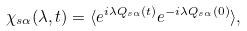<formula> <loc_0><loc_0><loc_500><loc_500>\chi _ { s \alpha } ( \lambda , t ) = \langle e ^ { i \lambda Q _ { s \alpha } ( t ) } e ^ { - i \lambda Q _ { s \alpha } ( 0 ) } \rangle ,</formula> 